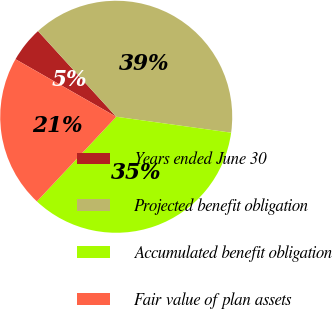Convert chart. <chart><loc_0><loc_0><loc_500><loc_500><pie_chart><fcel>Years ended June 30<fcel>Projected benefit obligation<fcel>Accumulated benefit obligation<fcel>Fair value of plan assets<nl><fcel>4.96%<fcel>38.97%<fcel>34.79%<fcel>21.28%<nl></chart> 